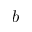Convert formula to latex. <formula><loc_0><loc_0><loc_500><loc_500>b</formula> 